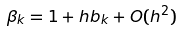<formula> <loc_0><loc_0><loc_500><loc_500>\beta _ { k } = 1 + h b _ { k } + O ( h ^ { 2 } )</formula> 